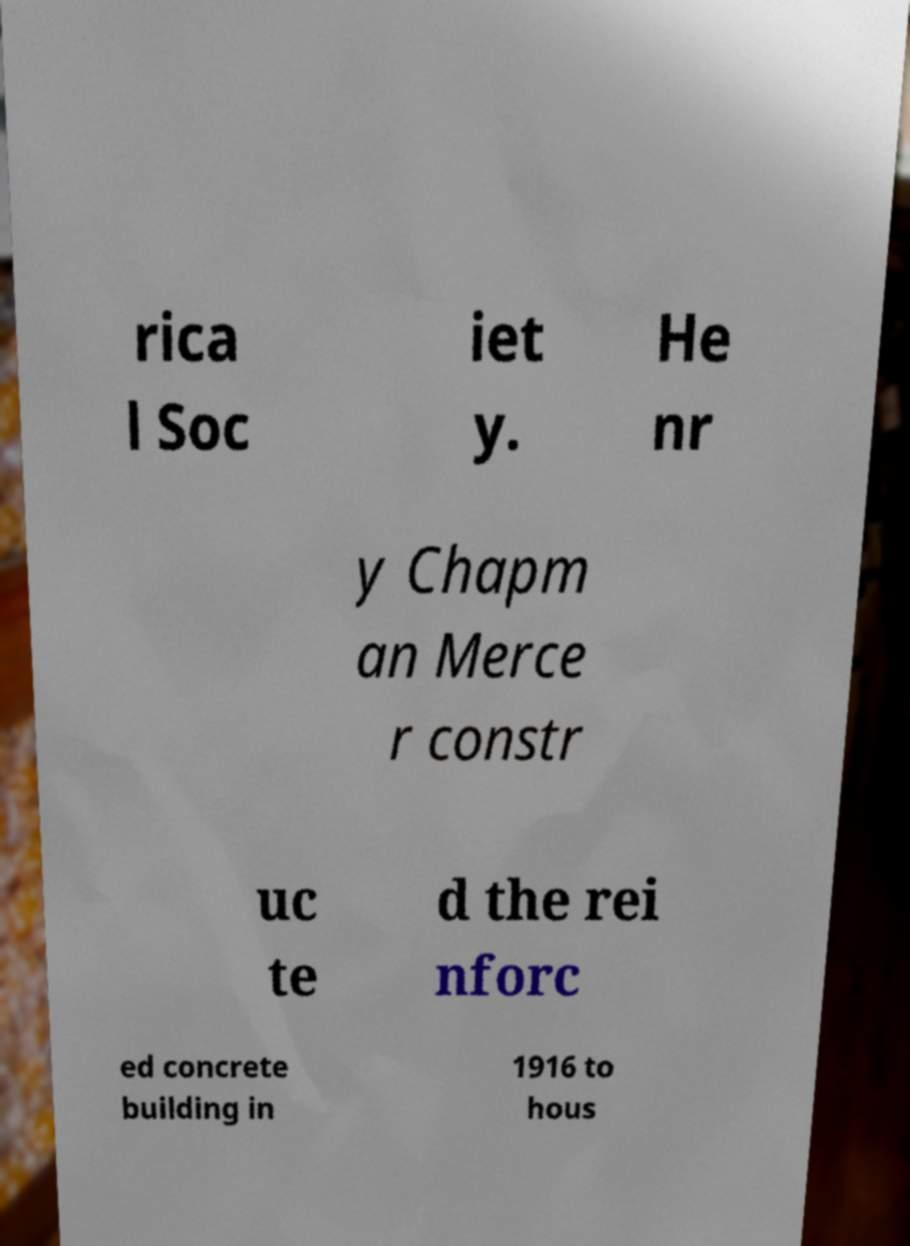Please read and relay the text visible in this image. What does it say? rica l Soc iet y. He nr y Chapm an Merce r constr uc te d the rei nforc ed concrete building in 1916 to hous 